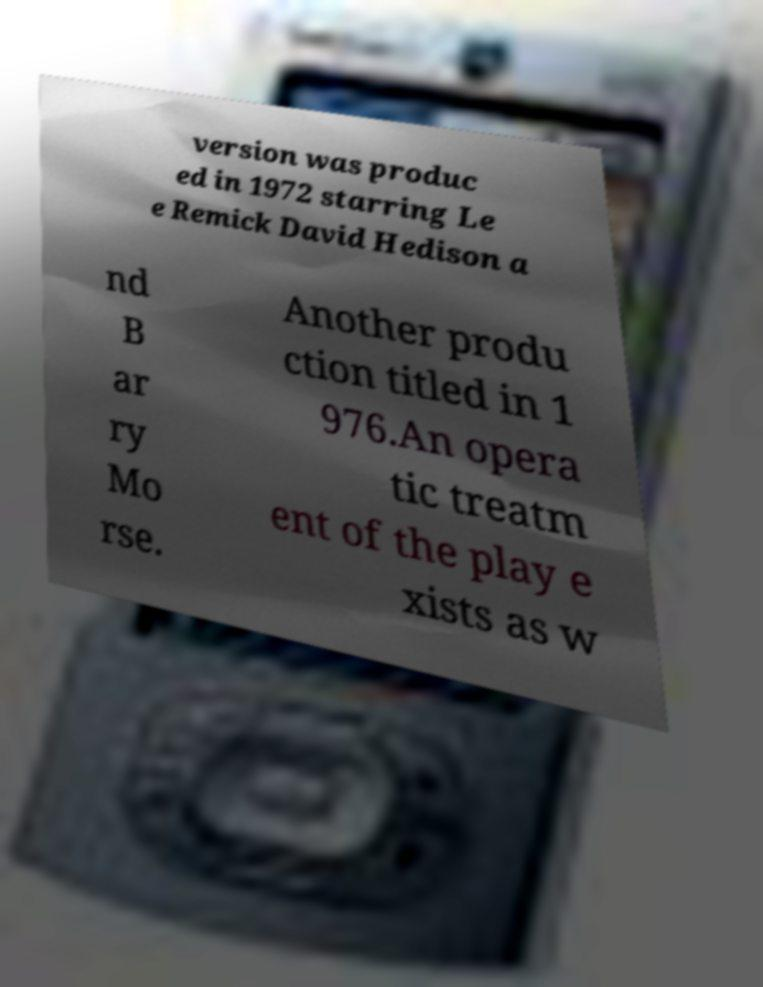Could you assist in decoding the text presented in this image and type it out clearly? version was produc ed in 1972 starring Le e Remick David Hedison a nd B ar ry Mo rse. Another produ ction titled in 1 976.An opera tic treatm ent of the play e xists as w 